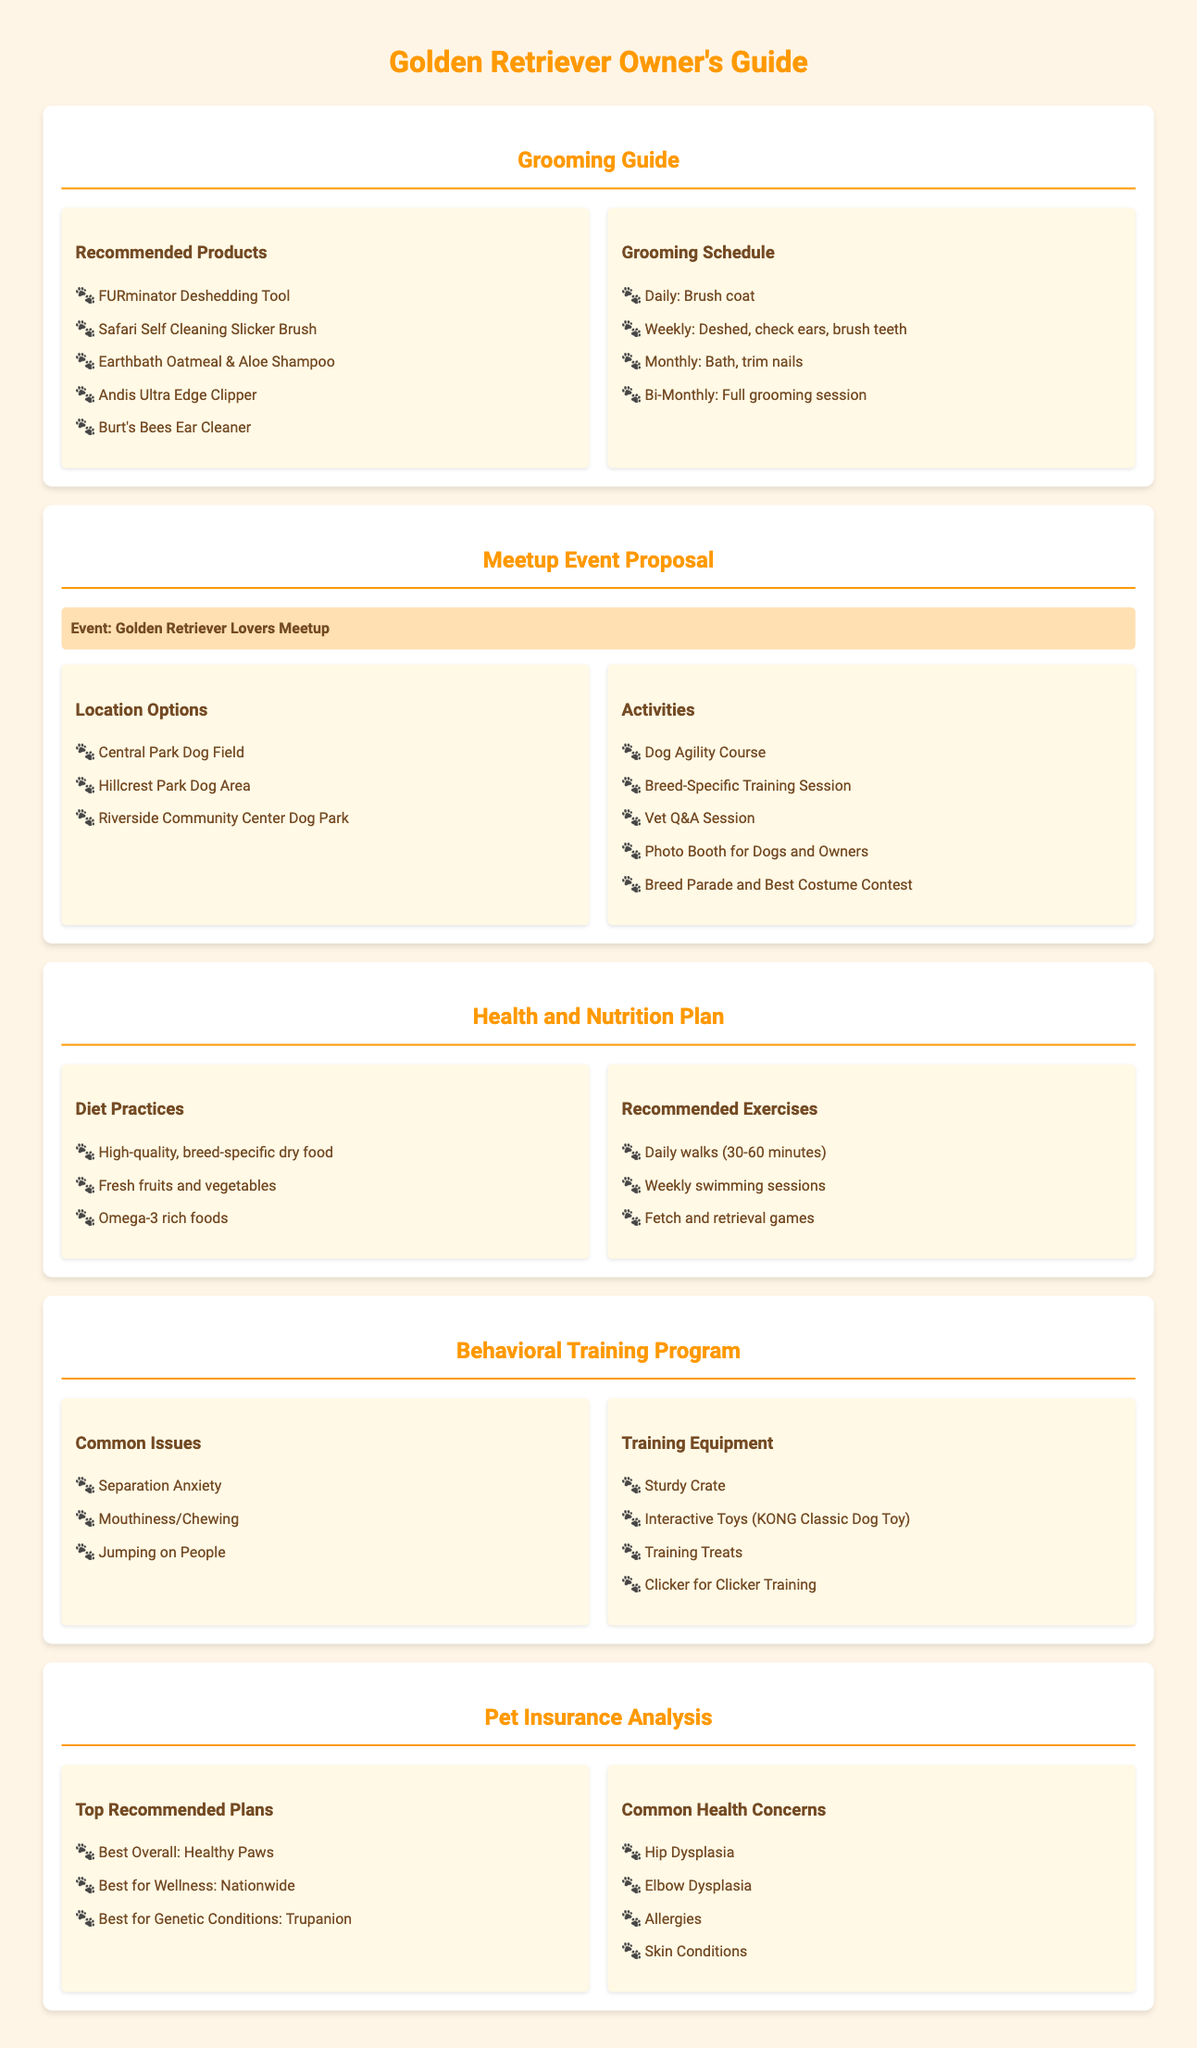What are the recommended grooming products? The document lists several grooming products specifically for Golden Retrievers, such as the FURminator Deshedding Tool and Earthbath Oatmeal & Aloe Shampoo.
Answer: FURminator Deshedding Tool, Earthbath Oatmeal & Aloe Shampoo How often should you check ears according to the grooming schedule? The grooming schedule specifies that checking ears should be done weekly.
Answer: Weekly What is one of the activities planned for the meetup event? The document mentions multiple activities, including a Dog Agility Course, as part of the meetup event.
Answer: Dog Agility Course What is a common health concern for Golden Retrievers? The document outlines several health issues, with Hip Dysplasia being one of the most common concerns.
Answer: Hip Dysplasia What kind of exercise is recommended for Golden Retrievers? The health and nutrition plan advises daily walks as a key exercise for overall wellbeing.
Answer: Daily walks Which pet insurance plan is listed as best for wellness? The document evaluates various plans and identifies Nationwide as the best for wellness.
Answer: Nationwide What should be used for training as per the behavioral training program? The program highlights several items, including training treats and clickers for effective training.
Answer: Training treats What is the proposed event title for the meetup? The document mentions the event title as "Golden Retriever Lovers Meetup."
Answer: Golden Retriever Lovers Meetup What is the frequency of full grooming sessions recommended? The grooming guide suggests that full grooming sessions should be conducted bi-monthly.
Answer: Bi-Monthly What is a specific diet practice suggested for Golden Retrievers? The health and nutrition section specifies that a high-quality, breed-specific dry food should be a part of their diet.
Answer: High-quality, breed-specific dry food 